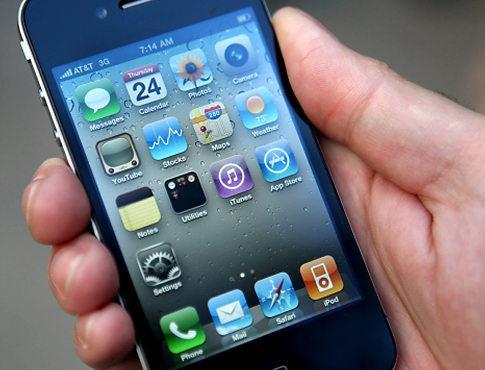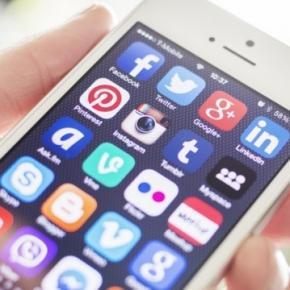The first image is the image on the left, the second image is the image on the right. Considering the images on both sides, is "A group of phones lies together in the image on the right." valid? Answer yes or no. No. The first image is the image on the left, the second image is the image on the right. For the images shown, is this caption "One of the phones reads 2:42 PM." true? Answer yes or no. No. 